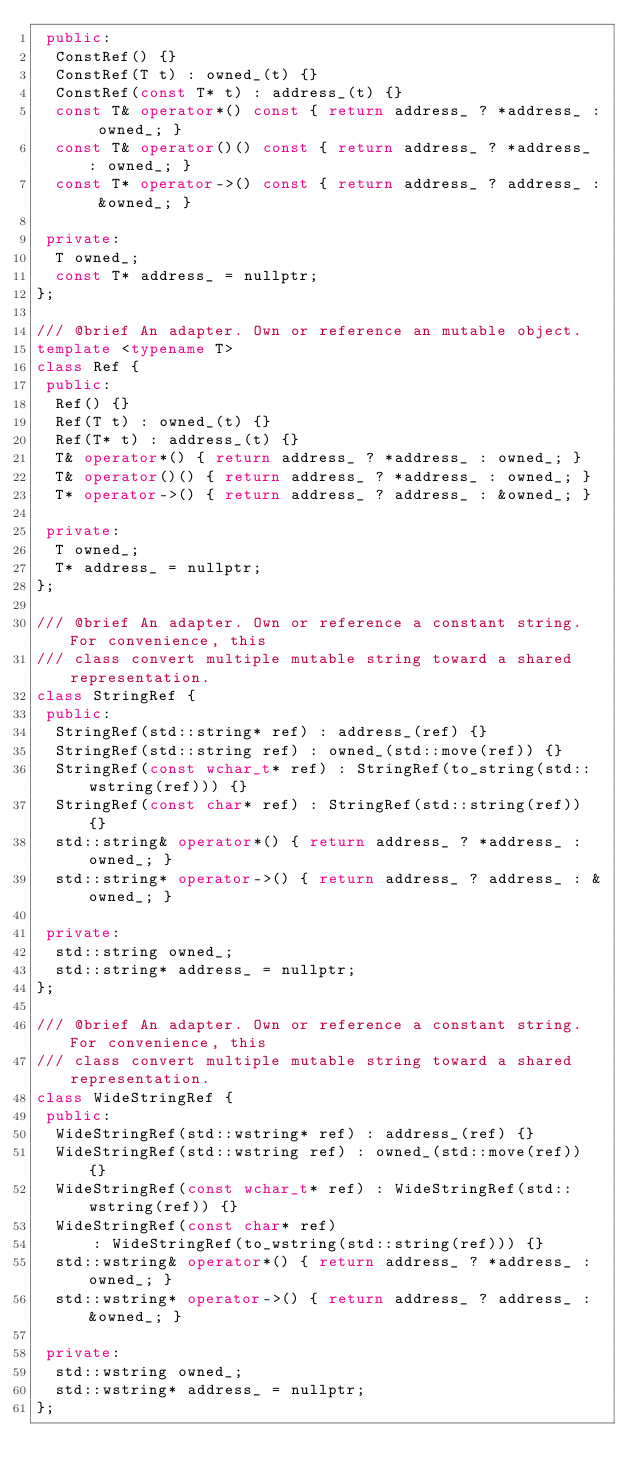<code> <loc_0><loc_0><loc_500><loc_500><_C++_> public:
  ConstRef() {}
  ConstRef(T t) : owned_(t) {}
  ConstRef(const T* t) : address_(t) {}
  const T& operator*() const { return address_ ? *address_ : owned_; }
  const T& operator()() const { return address_ ? *address_ : owned_; }
  const T* operator->() const { return address_ ? address_ : &owned_; }

 private:
  T owned_;
  const T* address_ = nullptr;
};

/// @brief An adapter. Own or reference an mutable object.
template <typename T>
class Ref {
 public:
  Ref() {}
  Ref(T t) : owned_(t) {}
  Ref(T* t) : address_(t) {}
  T& operator*() { return address_ ? *address_ : owned_; }
  T& operator()() { return address_ ? *address_ : owned_; }
  T* operator->() { return address_ ? address_ : &owned_; }

 private:
  T owned_;
  T* address_ = nullptr;
};

/// @brief An adapter. Own or reference a constant string. For convenience, this
/// class convert multiple mutable string toward a shared representation.
class StringRef {
 public:
  StringRef(std::string* ref) : address_(ref) {}
  StringRef(std::string ref) : owned_(std::move(ref)) {}
  StringRef(const wchar_t* ref) : StringRef(to_string(std::wstring(ref))) {}
  StringRef(const char* ref) : StringRef(std::string(ref)) {}
  std::string& operator*() { return address_ ? *address_ : owned_; }
  std::string* operator->() { return address_ ? address_ : &owned_; }

 private:
  std::string owned_;
  std::string* address_ = nullptr;
};

/// @brief An adapter. Own or reference a constant string. For convenience, this
/// class convert multiple mutable string toward a shared representation.
class WideStringRef {
 public:
  WideStringRef(std::wstring* ref) : address_(ref) {}
  WideStringRef(std::wstring ref) : owned_(std::move(ref)) {}
  WideStringRef(const wchar_t* ref) : WideStringRef(std::wstring(ref)) {}
  WideStringRef(const char* ref)
      : WideStringRef(to_wstring(std::string(ref))) {}
  std::wstring& operator*() { return address_ ? *address_ : owned_; }
  std::wstring* operator->() { return address_ ? address_ : &owned_; }

 private:
  std::wstring owned_;
  std::wstring* address_ = nullptr;
};
</code> 